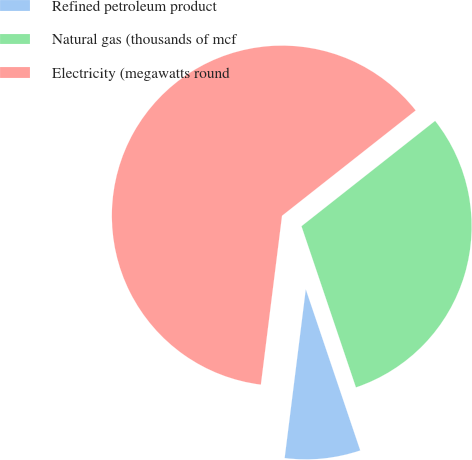<chart> <loc_0><loc_0><loc_500><loc_500><pie_chart><fcel>Refined petroleum product<fcel>Natural gas (thousands of mcf<fcel>Electricity (megawatts round<nl><fcel>7.17%<fcel>30.44%<fcel>62.4%<nl></chart> 